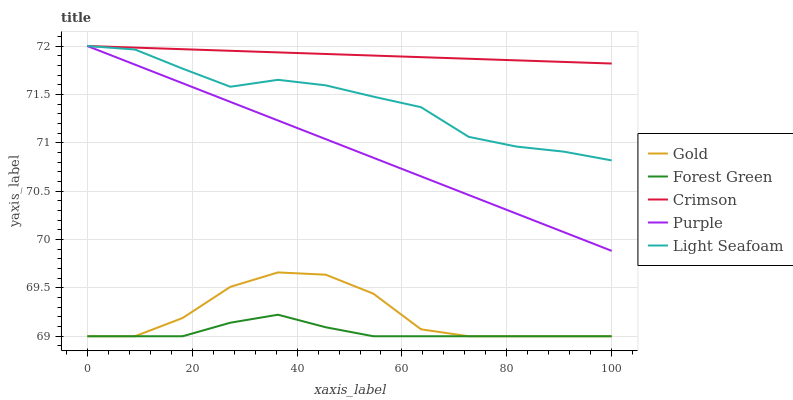Does Forest Green have the minimum area under the curve?
Answer yes or no. Yes. Does Crimson have the maximum area under the curve?
Answer yes or no. Yes. Does Purple have the minimum area under the curve?
Answer yes or no. No. Does Purple have the maximum area under the curve?
Answer yes or no. No. Is Purple the smoothest?
Answer yes or no. Yes. Is Gold the roughest?
Answer yes or no. Yes. Is Forest Green the smoothest?
Answer yes or no. No. Is Forest Green the roughest?
Answer yes or no. No. Does Forest Green have the lowest value?
Answer yes or no. Yes. Does Purple have the lowest value?
Answer yes or no. No. Does Light Seafoam have the highest value?
Answer yes or no. Yes. Does Forest Green have the highest value?
Answer yes or no. No. Is Forest Green less than Purple?
Answer yes or no. Yes. Is Light Seafoam greater than Forest Green?
Answer yes or no. Yes. Does Forest Green intersect Gold?
Answer yes or no. Yes. Is Forest Green less than Gold?
Answer yes or no. No. Is Forest Green greater than Gold?
Answer yes or no. No. Does Forest Green intersect Purple?
Answer yes or no. No. 